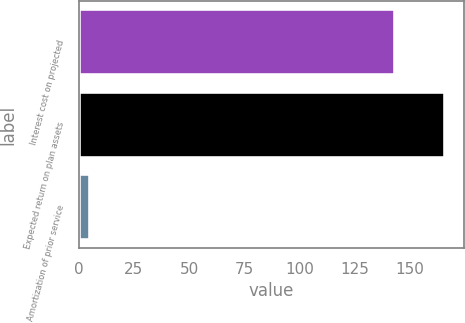<chart> <loc_0><loc_0><loc_500><loc_500><bar_chart><fcel>Interest cost on projected<fcel>Expected return on plan assets<fcel>Amortization of prior service<nl><fcel>143<fcel>166<fcel>5<nl></chart> 